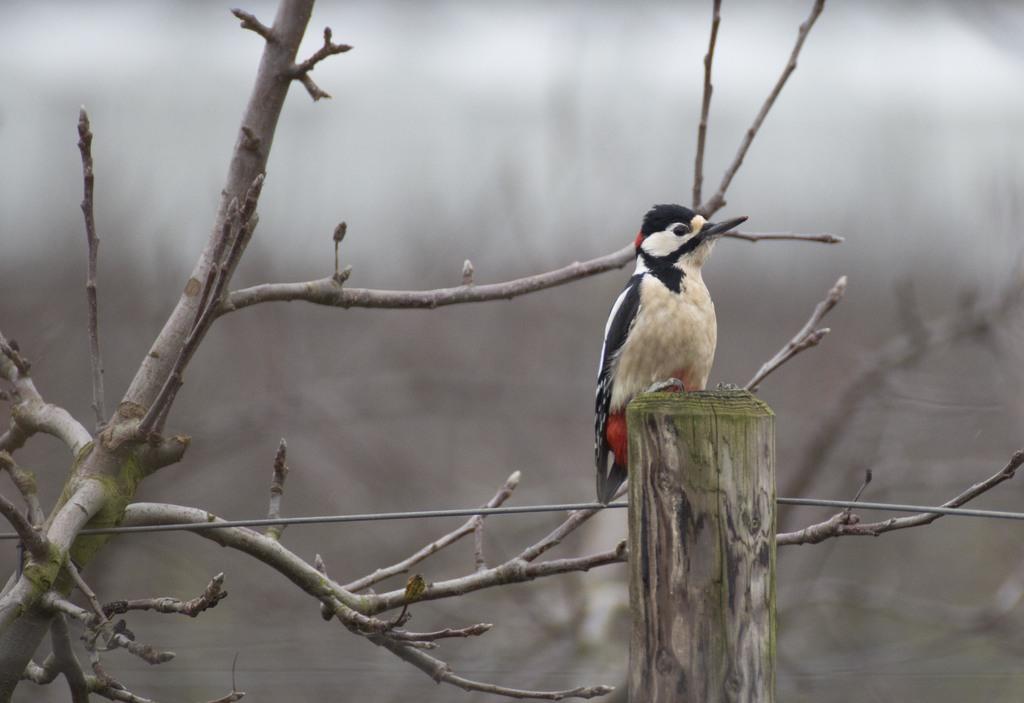Describe this image in one or two sentences. This is the picture of a bird which is on the wooden stick and to the side there is a tree stem. 